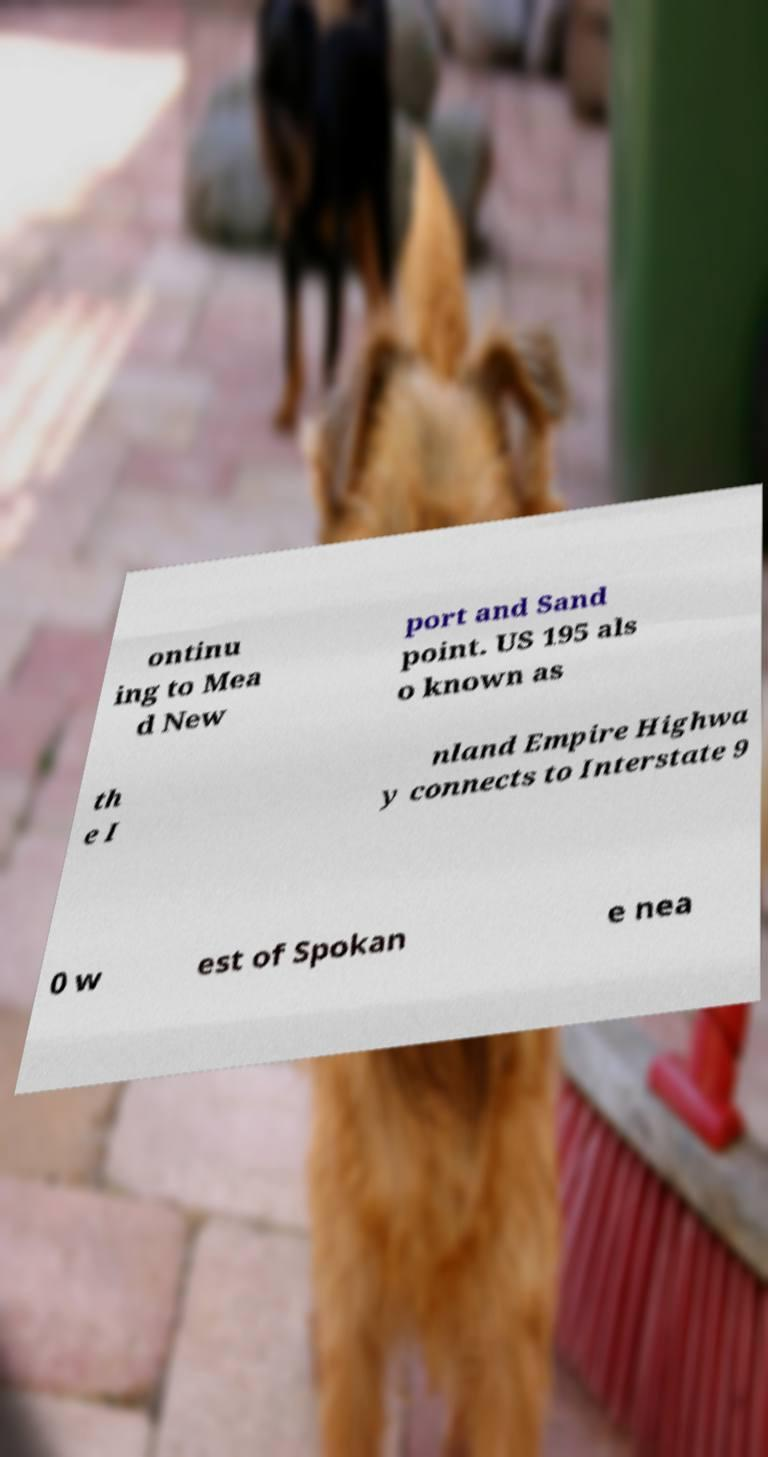There's text embedded in this image that I need extracted. Can you transcribe it verbatim? ontinu ing to Mea d New port and Sand point. US 195 als o known as th e I nland Empire Highwa y connects to Interstate 9 0 w est of Spokan e nea 